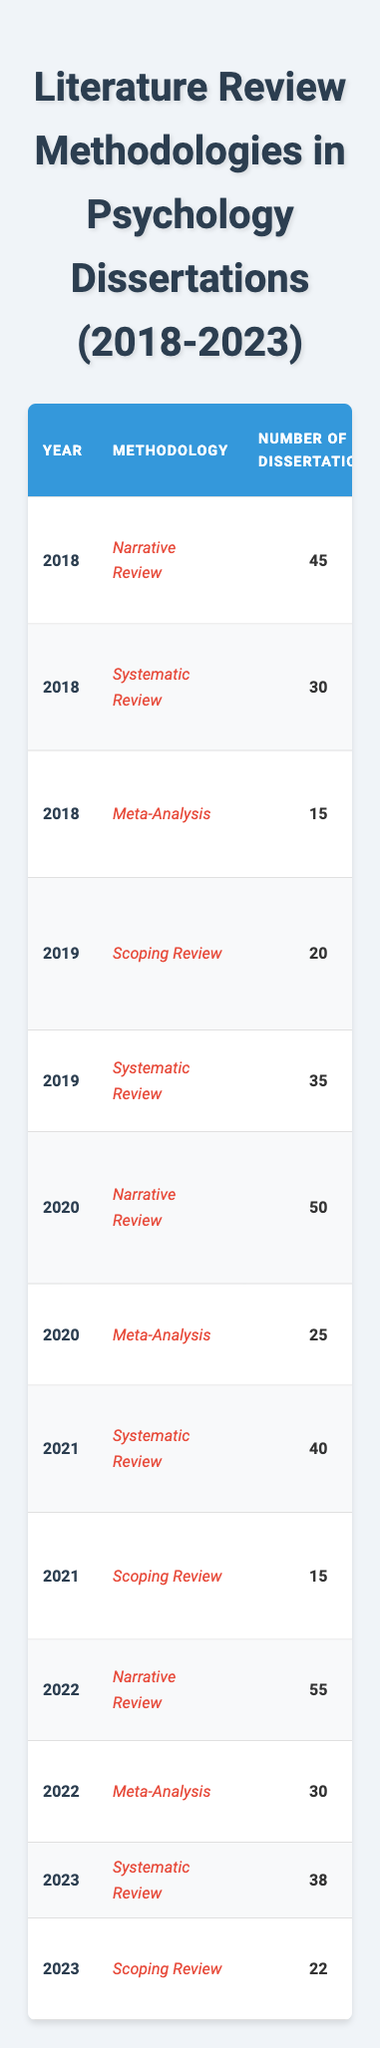What was the total number of dissertations using the Narrative Review methodology from 2018 to 2023? The table shows that in 2018 there were 45 dissertations, in 2020 there were 50 dissertations, and in 2022 there were 55 dissertations using the Narrative Review methodology. Adding these up gives 45 + 50 + 55 = 150.
Answer: 150 What is the average word count of dissertations utilizing Meta-Analysis? The average word counts for Meta-Analysis are 18,000 in 2018, 17,000 in 2020, and 17,500 in 2022. The average can be calculated as (18000 + 17000 + 17500) / 3, which equals 17400.
Answer: 17,400 Which year saw the highest number of dissertations using Systematic Review methodology? By examining the table, in 2018 there were 30, in 2019 there were 35, in 2020, there were none, in 2021 there were 40, and in 2023 there were 38. Thus, 2021 had the highest at 40.
Answer: 2021 What was the predominant topic among dissertations that used Scoping Review methodology in 2019? The table indicates that the predominant topics for Scoping Review in 2019 were Educational Psychology and Industrial-Organizational Psychology.
Answer: Educational Psychology, Industrial-Organizational Psychology Is the average word count of dissertations using the Scoping Review methodology higher than that of the Meta-Analysis? The average word count for Scoping Review is 13,000 in 2019, 14,000 in 2021, and 13,500 in 2023, with an average of (13000 + 14000 + 13500) / 3 = 13400. For Meta-Analysis, the average is 17,400 from previous calculation. Thus, 13,400 is less than 17,400.
Answer: No Which publishing company has been the most common publisher across all methodologies from 2018 to 2023? By reviewing the table, the most common publishers for each methodology include American Psychological Association, Wiley-Blackwell, Springer, Taylor & Francis, SAGE Publications, Cambridge University Press, Routledge, Psychological Science, BMC Psychology, Oxford University Press, Guilford Press, and Frontiers in Psychology. No repetition indicates there's no most common across all.
Answer: None How many dissertations were published under the Systematic Review methodology across all years? The counts for Systematic Review are 30 in 2018, 35 in 2019, 40 in 2021, and 38 in 2023. Adding these gives 30 + 35 + 40 + 38 = 143.
Answer: 143 What is the difference in average word count between the Meta-Analysis and the Narrative Review methodologies? The average for Meta-Analysis is 17,400 as calculated before, and for Narrative Review, it is (12000 + 12500 + 12800) / 3 = 12300. The difference then is 17400 - 12300 = 5100.
Answer: 5,100 Which methodology had the least number of dissertations in 2021? The Scoping Review had 15 dissertations compared to Systematic Review with 40, which is the only other methodology from that year.
Answer: Scoping Review What are the predominant topics of dissertations for the Meta-Analysis methodology in 2022? Looking at the table, the topics under Meta-Analysis for 2022 are Anxiety Disorders and Child Psychology.
Answer: Anxiety Disorders, Child Psychology 